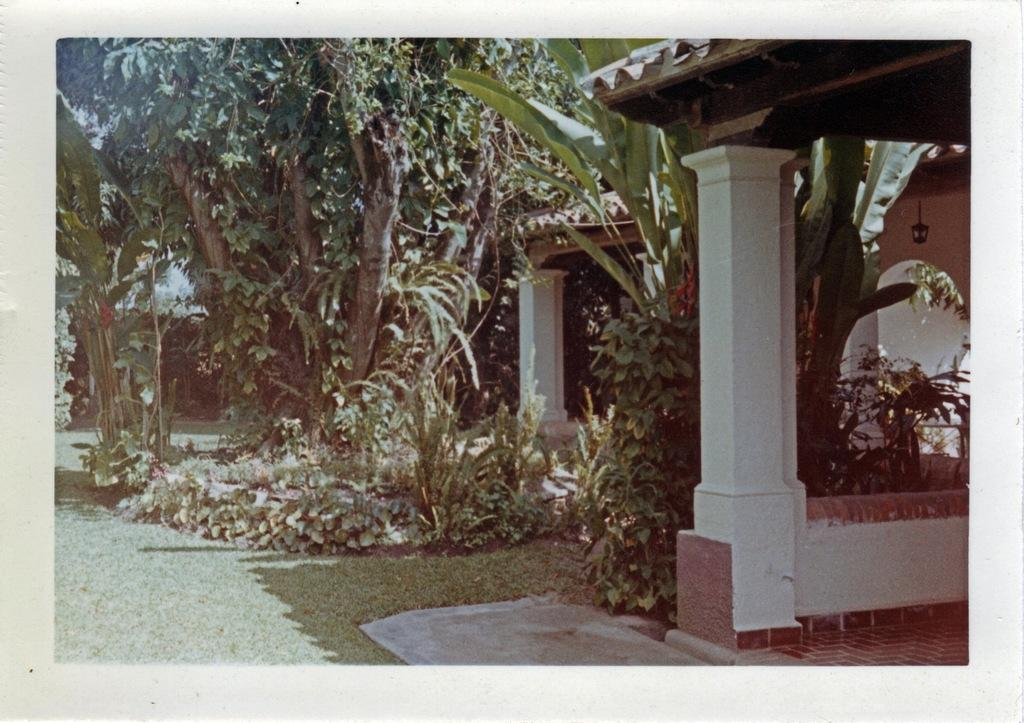What is depicted in the image? There is a picture of a house in the image. What features can be observed on the house? The house has a roof and pillars. What type of vegetation is present in the image? There are plants, grass, and trees in the image. Can you tell me how many deer are visible in the image? There are no deer present in the image. What type of oil is being used to maintain the house in the image? There is no mention of oil being used to maintain the house in the image. 